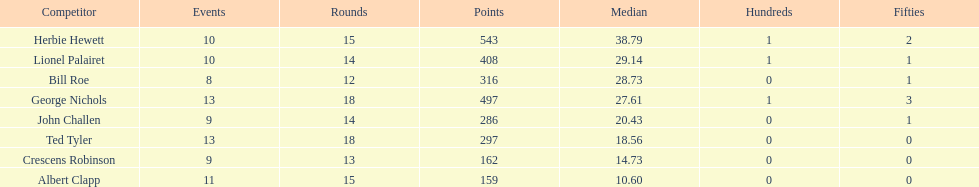What is the least about of runs anyone has? 159. 